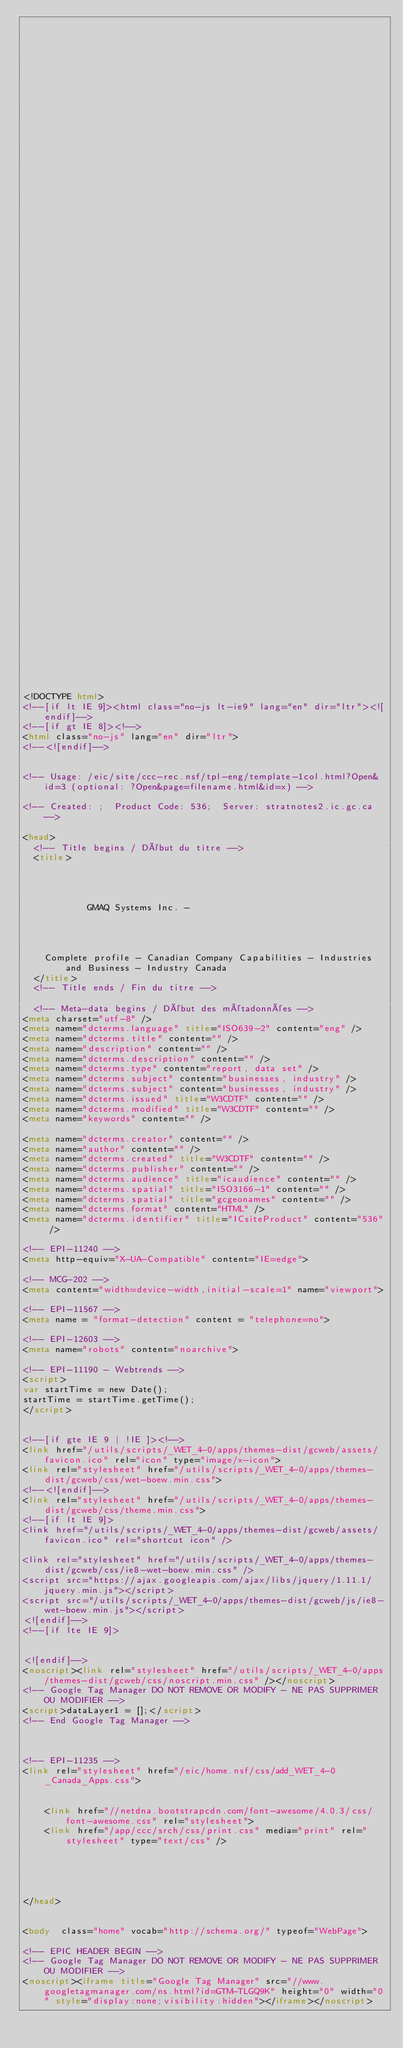Convert code to text. <code><loc_0><loc_0><loc_500><loc_500><_HTML_>


















	






  
  
  
  































	
	
	



<!DOCTYPE html>
<!--[if lt IE 9]><html class="no-js lt-ie9" lang="en" dir="ltr"><![endif]-->
<!--[if gt IE 8]><!-->
<html class="no-js" lang="en" dir="ltr">
<!--<![endif]-->


<!-- Usage: /eic/site/ccc-rec.nsf/tpl-eng/template-1col.html?Open&id=3 (optional: ?Open&page=filename.html&id=x) -->

<!-- Created: ;  Product Code: 536;  Server: stratnotes2.ic.gc.ca -->

<head>
	<!-- Title begins / Début du titre -->
	<title>
    
            
        
          
            GMAQ Systems Inc. -
          
        
      
    
    Complete profile - Canadian Company Capabilities - Industries and Business - Industry Canada
  </title>
	<!-- Title ends / Fin du titre -->
 
	<!-- Meta-data begins / Début des métadonnées -->
<meta charset="utf-8" />
<meta name="dcterms.language" title="ISO639-2" content="eng" />
<meta name="dcterms.title" content="" />
<meta name="description" content="" />
<meta name="dcterms.description" content="" />
<meta name="dcterms.type" content="report, data set" />
<meta name="dcterms.subject" content="businesses, industry" />
<meta name="dcterms.subject" content="businesses, industry" />
<meta name="dcterms.issued" title="W3CDTF" content="" />
<meta name="dcterms.modified" title="W3CDTF" content="" />
<meta name="keywords" content="" />

<meta name="dcterms.creator" content="" />
<meta name="author" content="" />
<meta name="dcterms.created" title="W3CDTF" content="" />
<meta name="dcterms.publisher" content="" />
<meta name="dcterms.audience" title="icaudience" content="" />
<meta name="dcterms.spatial" title="ISO3166-1" content="" />
<meta name="dcterms.spatial" title="gcgeonames" content="" />
<meta name="dcterms.format" content="HTML" />
<meta name="dcterms.identifier" title="ICsiteProduct" content="536" />

<!-- EPI-11240 -->
<meta http-equiv="X-UA-Compatible" content="IE=edge">

<!-- MCG-202 -->
<meta content="width=device-width,initial-scale=1" name="viewport">

<!-- EPI-11567 -->
<meta name = "format-detection" content = "telephone=no">

<!-- EPI-12603 -->
<meta name="robots" content="noarchive">

<!-- EPI-11190 - Webtrends -->
<script>
var startTime = new Date();
startTime = startTime.getTime();
</script>


<!--[if gte IE 9 | !IE ]><!-->
<link href="/utils/scripts/_WET_4-0/apps/themes-dist/gcweb/assets/favicon.ico" rel="icon" type="image/x-icon">
<link rel="stylesheet" href="/utils/scripts/_WET_4-0/apps/themes-dist/gcweb/css/wet-boew.min.css">
<!--<![endif]-->
<link rel="stylesheet" href="/utils/scripts/_WET_4-0/apps/themes-dist/gcweb/css/theme.min.css">
<!--[if lt IE 9]>
<link href="/utils/scripts/_WET_4-0/apps/themes-dist/gcweb/assets/favicon.ico" rel="shortcut icon" />

<link rel="stylesheet" href="/utils/scripts/_WET_4-0/apps/themes-dist/gcweb/css/ie8-wet-boew.min.css" />
<script src="https://ajax.googleapis.com/ajax/libs/jquery/1.11.1/jquery.min.js"></script>
<script src="/utils/scripts/_WET_4-0/apps/themes-dist/gcweb/js/ie8-wet-boew.min.js"></script>
<![endif]-->
<!--[if lte IE 9]>


<![endif]-->
<noscript><link rel="stylesheet" href="/utils/scripts/_WET_4-0/apps/themes-dist/gcweb/css/noscript.min.css" /></noscript>
<!-- Google Tag Manager DO NOT REMOVE OR MODIFY - NE PAS SUPPRIMER OU MODIFIER -->
<script>dataLayer1 = [];</script>
<!-- End Google Tag Manager -->



<!-- EPI-11235 -->
<link rel="stylesheet" href="/eic/home.nsf/css/add_WET_4-0_Canada_Apps.css">


  	<link href="//netdna.bootstrapcdn.com/font-awesome/4.0.3/css/font-awesome.css" rel="stylesheet">
  	<link href="/app/ccc/srch/css/print.css" media="print" rel="stylesheet" type="text/css" />
   




</head>
 

<body  class="home" vocab="http://schema.org/" typeof="WebPage">
 
<!-- EPIC HEADER BEGIN -->
<!-- Google Tag Manager DO NOT REMOVE OR MODIFY - NE PAS SUPPRIMER OU MODIFIER -->
<noscript><iframe title="Google Tag Manager" src="//www.googletagmanager.com/ns.html?id=GTM-TLGQ9K" height="0" width="0" style="display:none;visibility:hidden"></iframe></noscript></code> 